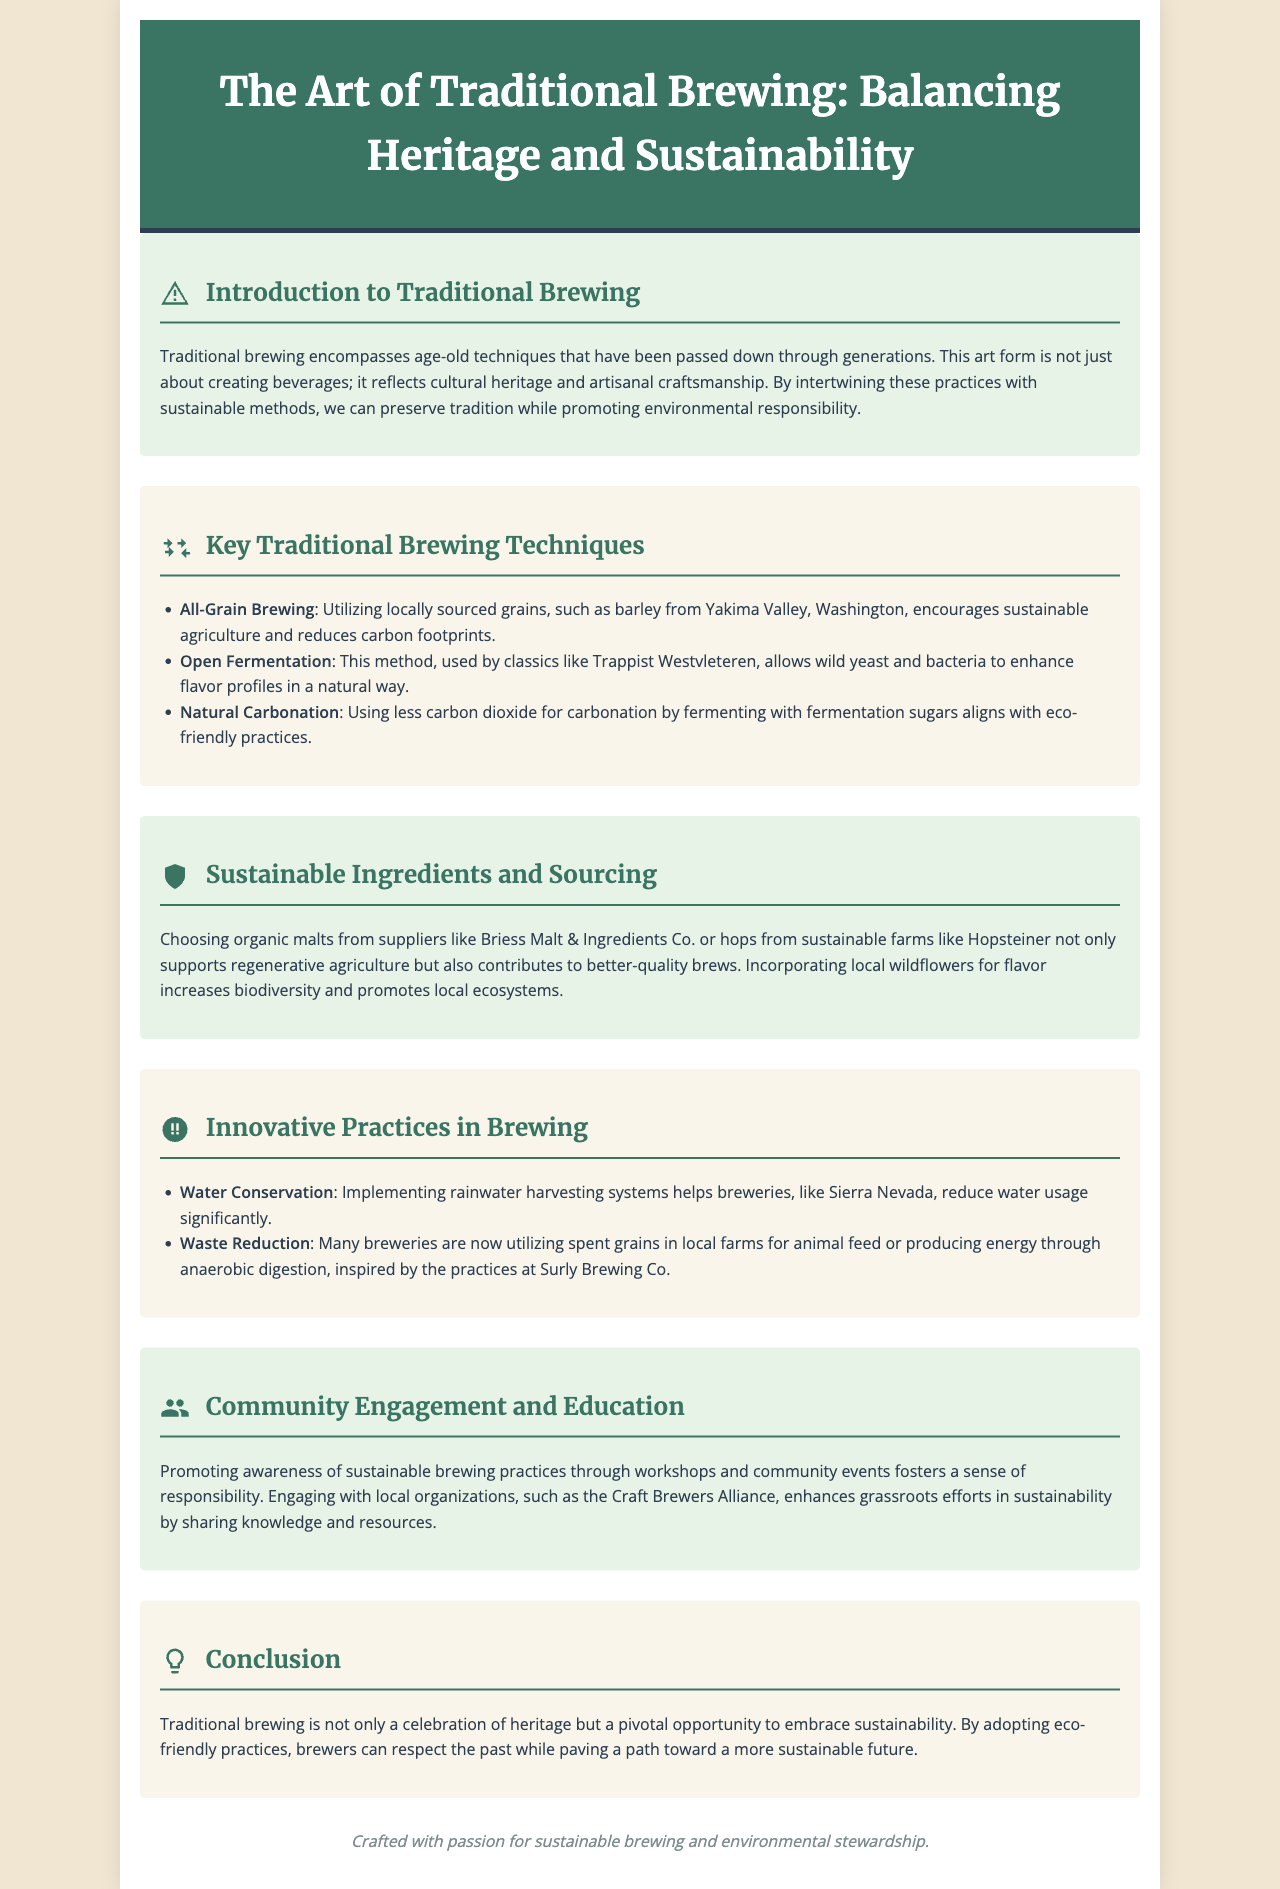What is the title of the brochure? The title can be found in the header section of the document.
Answer: The Art of Traditional Brewing: Balancing Heritage and Sustainability Who is the supplier of organic malts mentioned in the document? The supplier is referenced in the sustainable ingredients section.
Answer: Briess Malt & Ingredients Co What brewing method does Trappist Westvleteren use? This information is in the section about key traditional brewing techniques.
Answer: Open Fermentation What type of water conservation practice is mentioned? Details about practices can be found in the innovative practices section.
Answer: Rainwater harvesting What is the primary focus of the conclusion? The conclusion summarizes the main theme of the brochure.
Answer: Embrace sustainability How many brewing techniques are listed under key traditional brewing techniques? Counting the items in the list provides this information.
Answer: Three What is the main advantage of utilizing local wildflowers in brewing? The benefit is explored in the sustainable ingredients section.
Answer: Increases biodiversity Which brewery is noted for reducing water usage? This information is specifically mentioned in the innovative practices section.
Answer: Sierra Nevada What organization is mentioned in the community engagement section? The document references an organization for community involvement.
Answer: Craft Brewers Alliance 